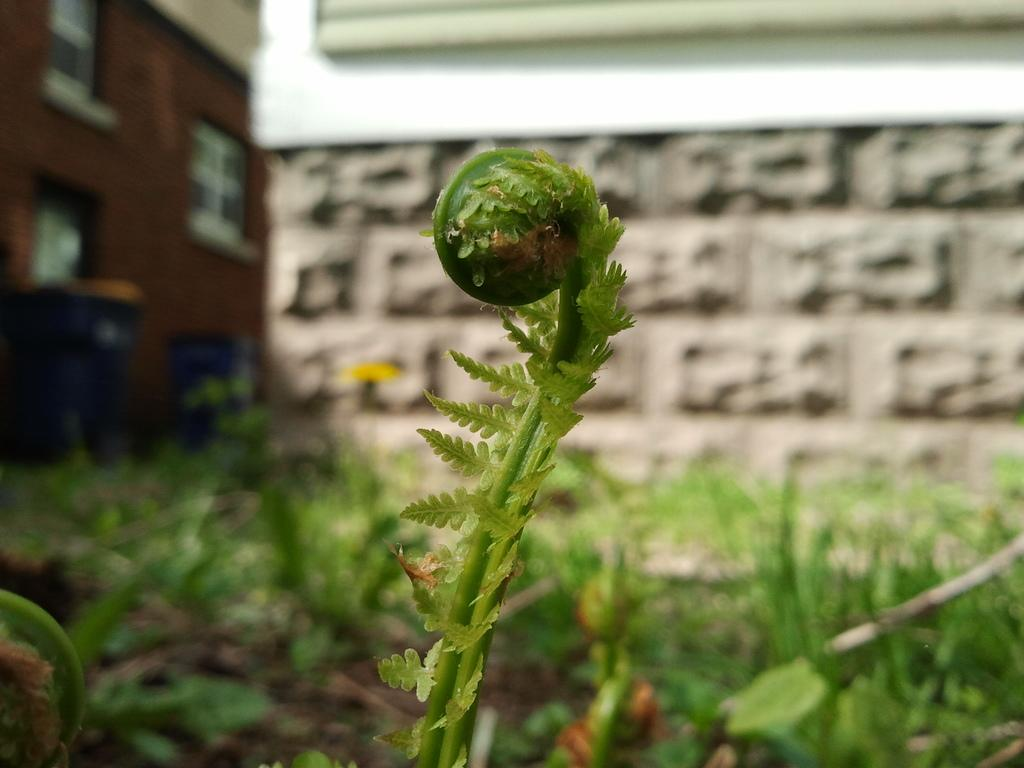What type of plants can be seen in the image? There are ferns and other plants in the image. How would you describe the background of the image? The background of the image is blurry. What structures are visible in the background of the image? There is a wall and a building visible in the background of the image. What type of receptacles are present in the background of the image? Dustbins are present in the background of the image. Can you see a giraffe in the park in the image? There is no giraffe or park present in the image. What type of plastic objects can be seen in the image? There is no plastic object present in the image. 